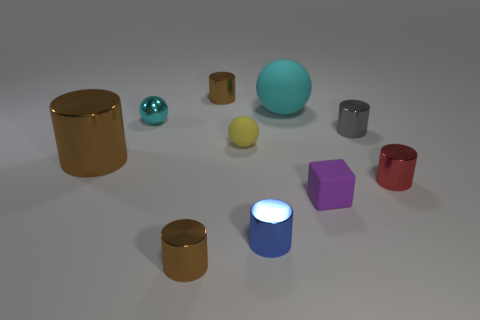How many brown cylinders must be subtracted to get 1 brown cylinders? 2 Subtract all red blocks. How many brown cylinders are left? 3 Subtract all red cylinders. How many cylinders are left? 5 Subtract all big cylinders. How many cylinders are left? 5 Subtract all cyan cylinders. Subtract all red balls. How many cylinders are left? 6 Subtract all cylinders. How many objects are left? 4 Add 4 small purple rubber blocks. How many small purple rubber blocks are left? 5 Add 9 large cyan matte balls. How many large cyan matte balls exist? 10 Subtract 0 yellow cylinders. How many objects are left? 10 Subtract all tiny green cubes. Subtract all small brown metallic objects. How many objects are left? 8 